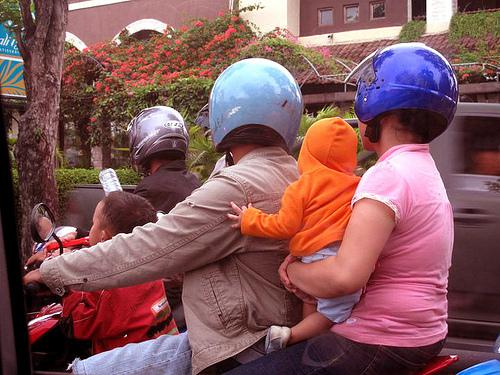Question: what are the people doing?
Choices:
A. Hiding.
B. Eating.
C. Riding.
D. Drinking.
Answer with the letter. Answer: C Question: how many people are on the motorcycle closest to the camera?
Choices:
A. Two.
B. One.
C. Four.
D. Zero.
Answer with the letter. Answer: C Question: how many children are on the motorcycle?
Choices:
A. Two.
B. Three.
C. One.
D. Five.
Answer with the letter. Answer: A Question: what color jacket is the baby wearing?
Choices:
A. Black.
B. Brown.
C. Red.
D. Orange.
Answer with the letter. Answer: D Question: what color are the flowers?
Choices:
A. Blue.
B. Purple.
C. Red.
D. Pink.
Answer with the letter. Answer: D 